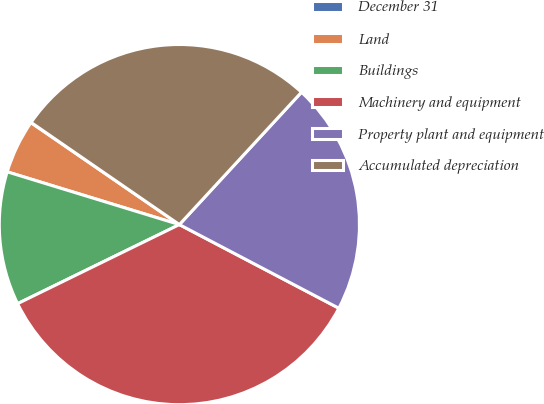<chart> <loc_0><loc_0><loc_500><loc_500><pie_chart><fcel>December 31<fcel>Land<fcel>Buildings<fcel>Machinery and equipment<fcel>Property plant and equipment<fcel>Accumulated depreciation<nl><fcel>0.03%<fcel>4.84%<fcel>11.97%<fcel>35.08%<fcel>20.83%<fcel>27.26%<nl></chart> 